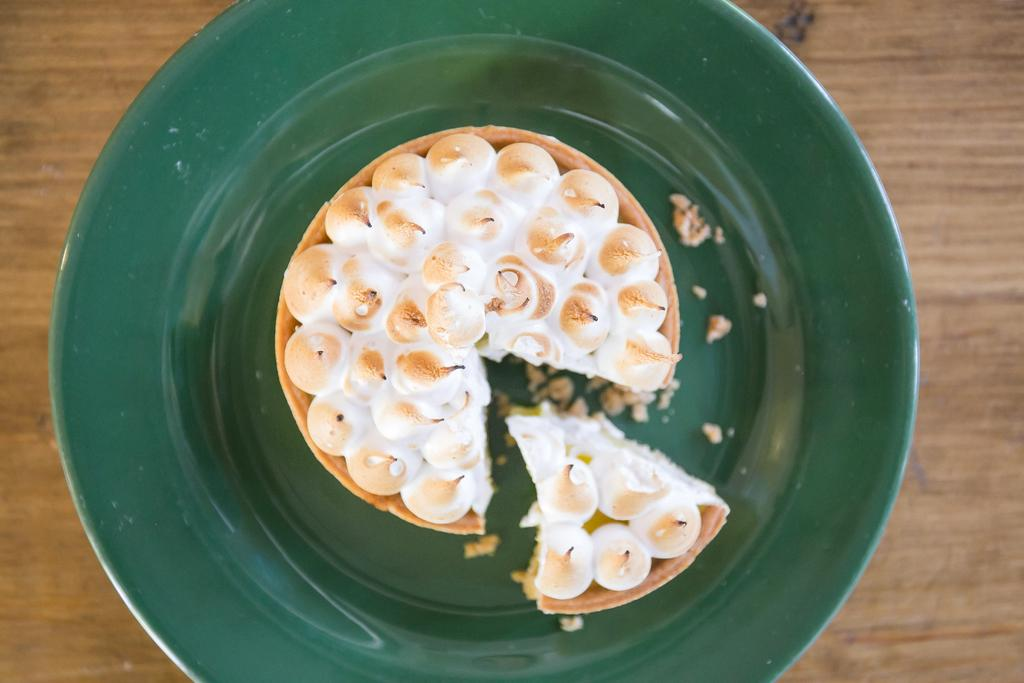What is on the plate that is visible in the image? The plate contains a cake. What is the color of the plate in the image? The plate is dark green in color. What material is the plate made of? The plate is a wooden board. How many rings are on the cake in the image? There are no rings visible on the cake in the image. What type of bears can be seen interacting with the cake in the image? There are no bears present in the image. 